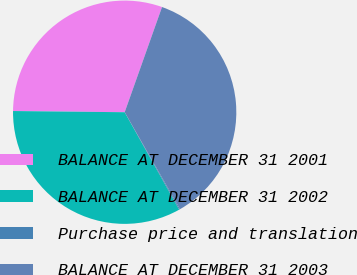Convert chart to OTSL. <chart><loc_0><loc_0><loc_500><loc_500><pie_chart><fcel>BALANCE AT DECEMBER 31 2001<fcel>BALANCE AT DECEMBER 31 2002<fcel>Purchase price and translation<fcel>BALANCE AT DECEMBER 31 2003<nl><fcel>30.26%<fcel>33.29%<fcel>0.14%<fcel>36.31%<nl></chart> 